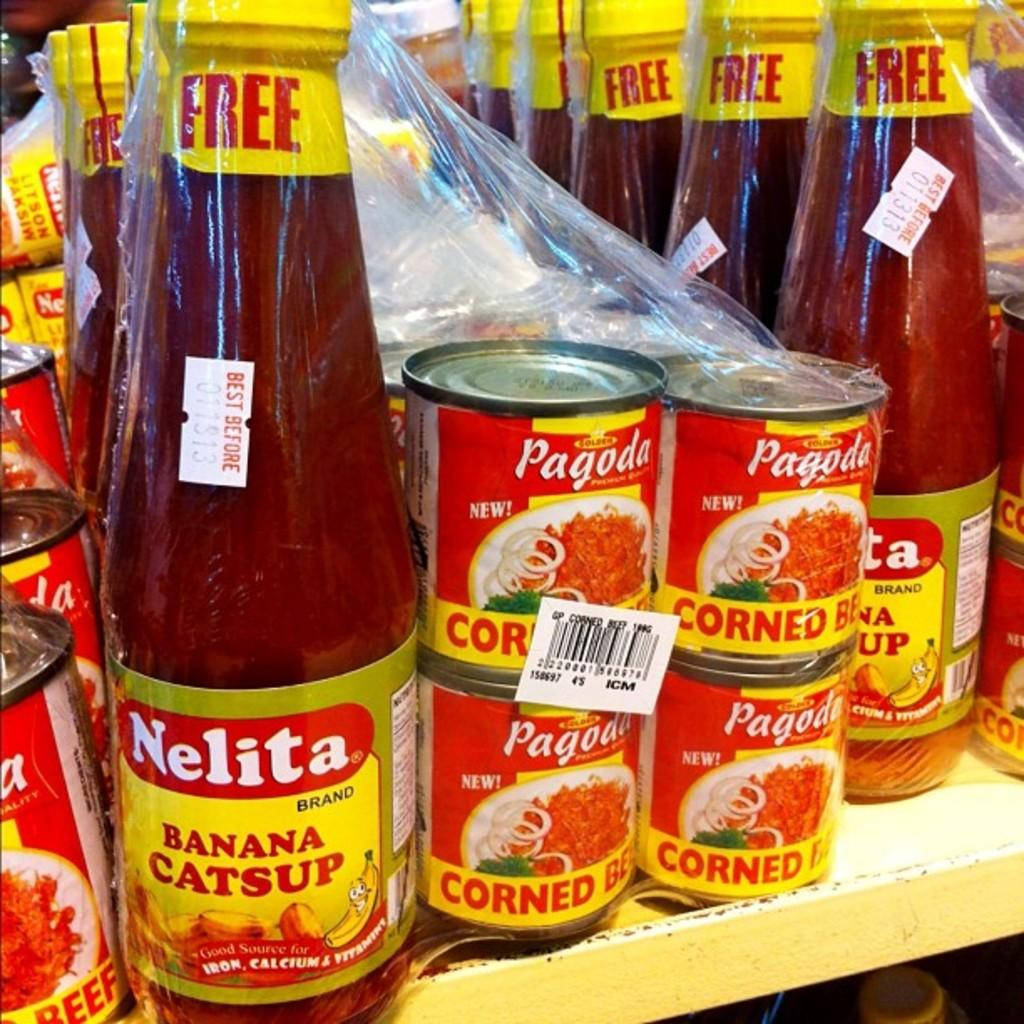<image>
Relay a brief, clear account of the picture shown. a shelf with Nelita Banana Catsup and Pagoda Corned Beef 